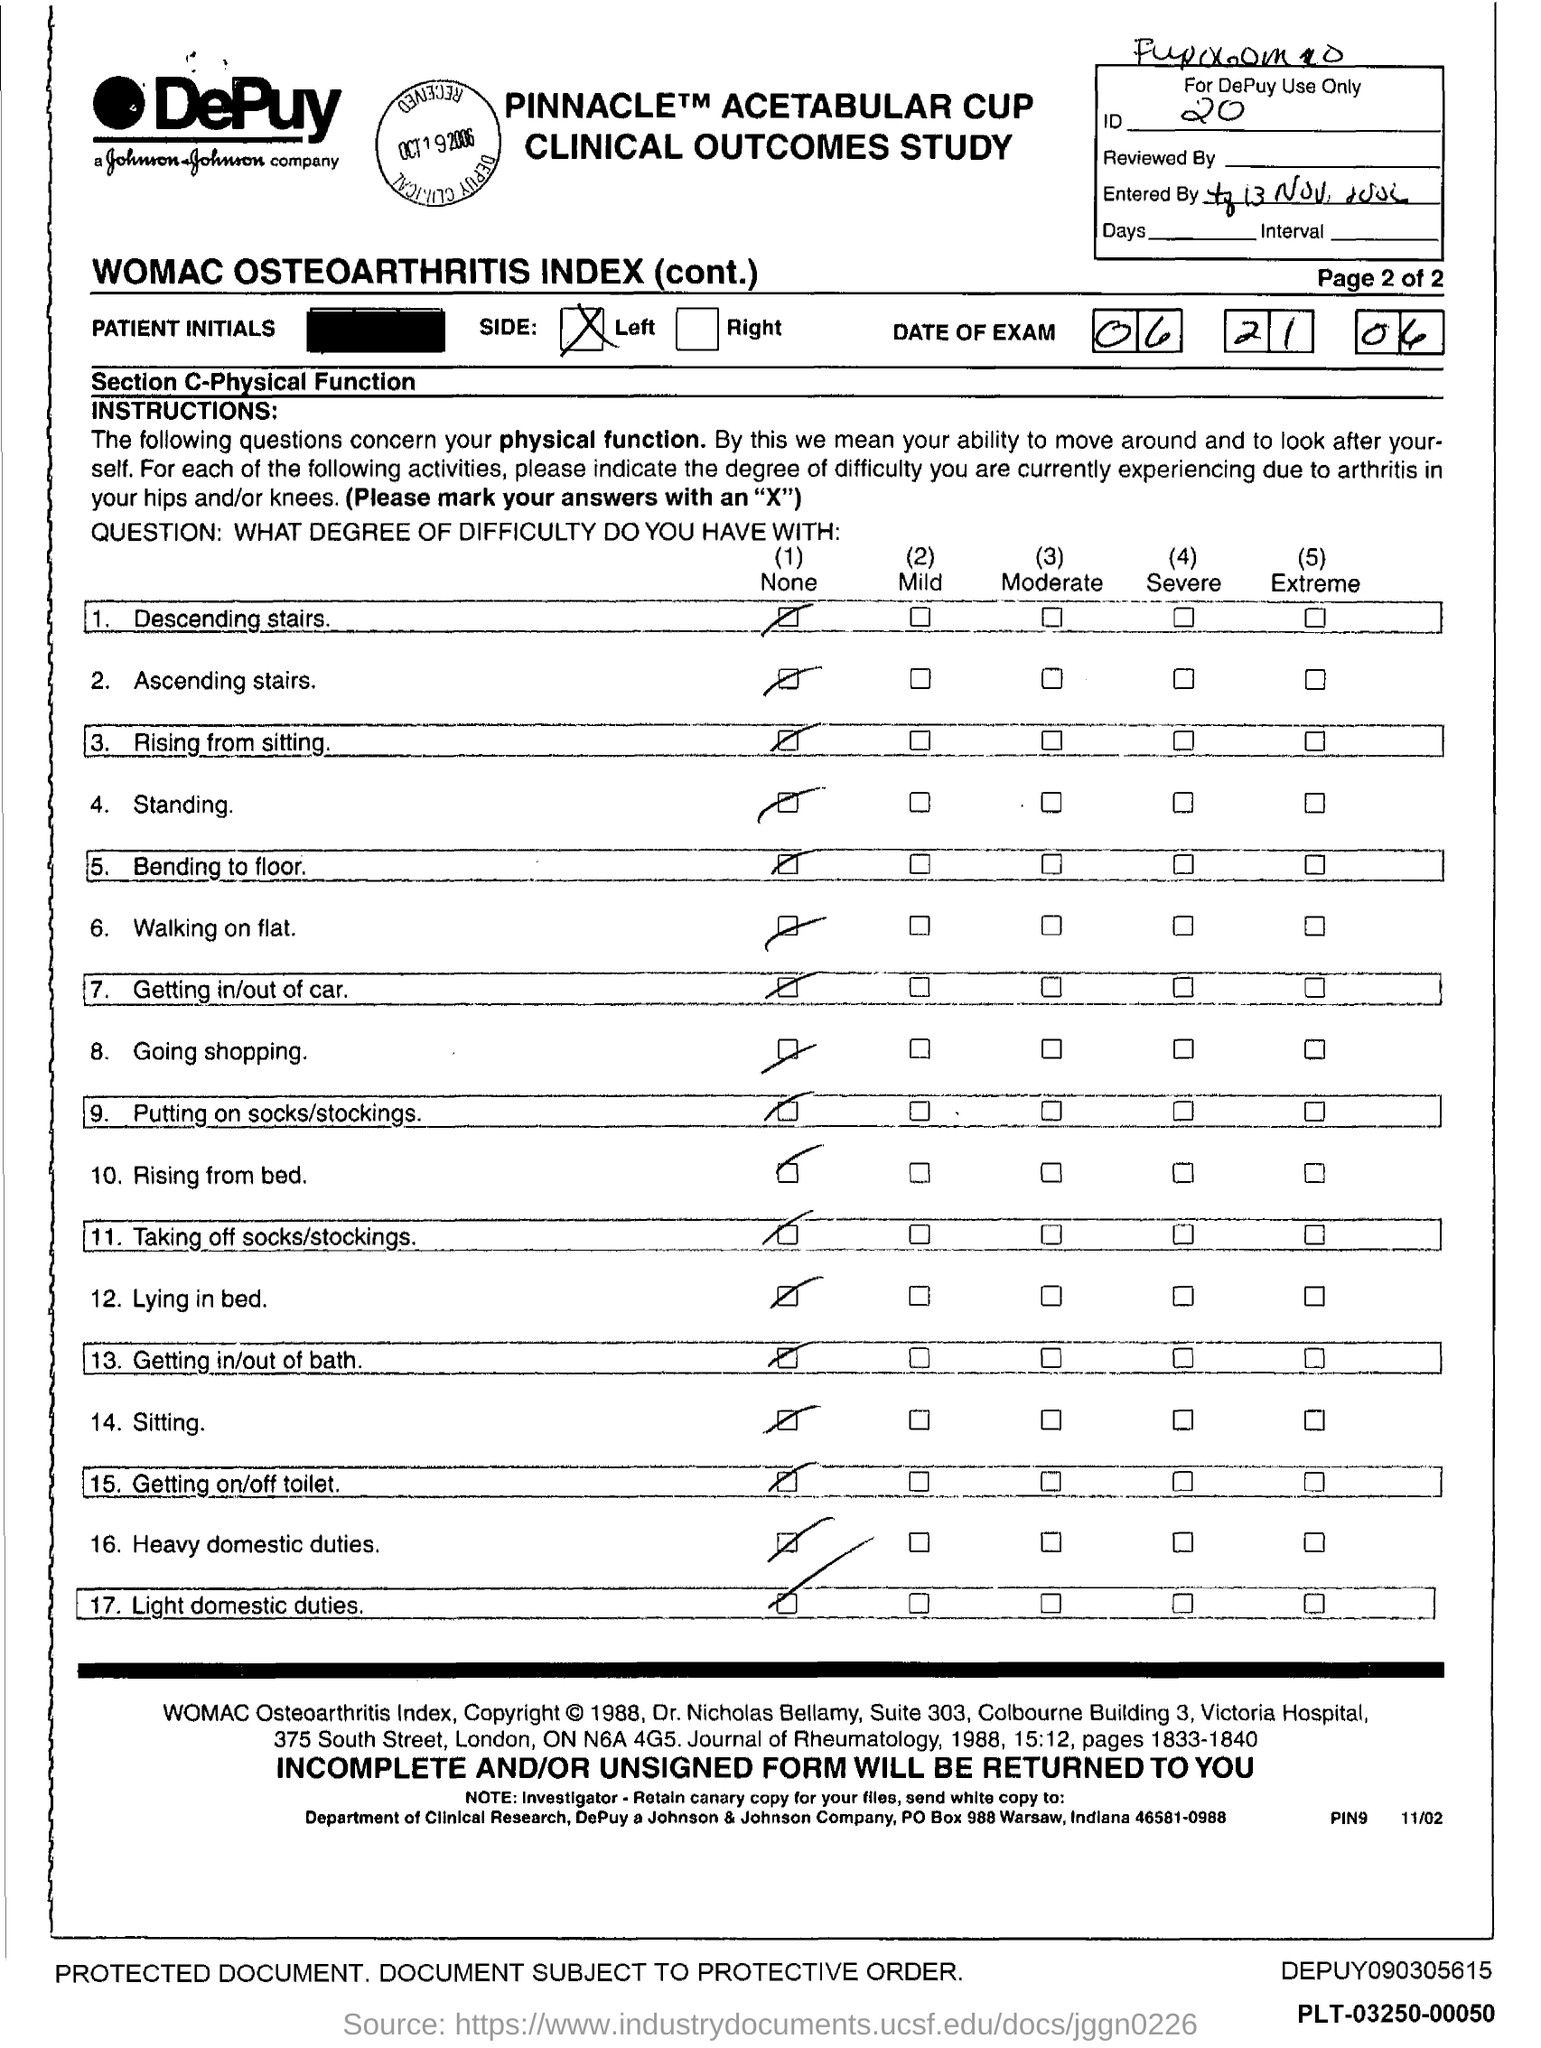Give some essential details in this illustration. Johnson & Johnson is located in the state of Indiana. The PO box number for Johnson & Johnson Company is 988. 